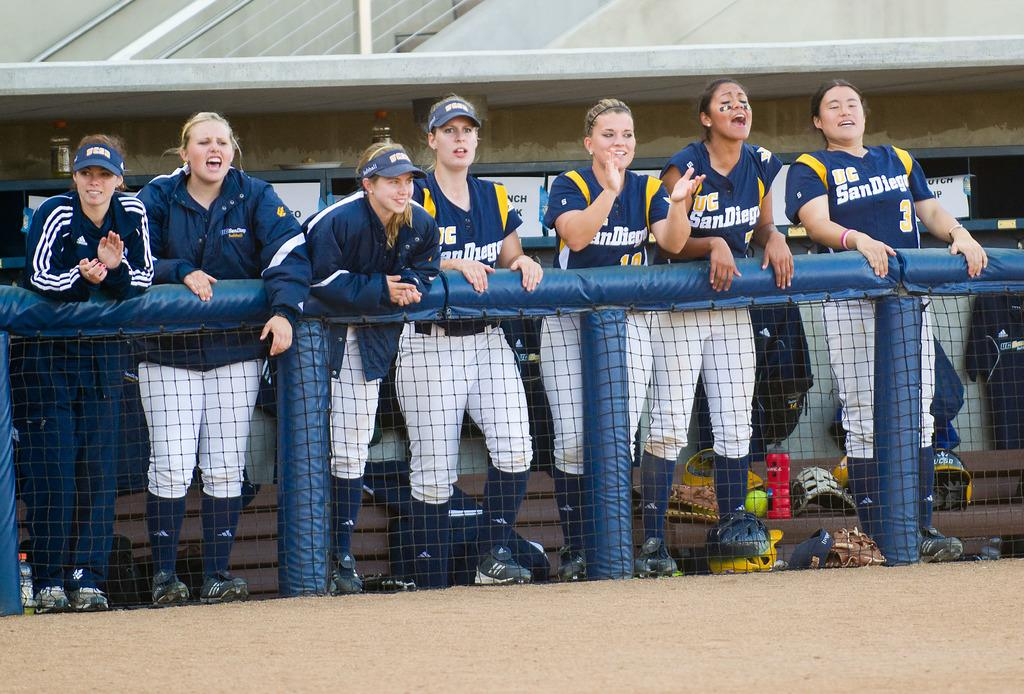<image>
Relay a brief, clear account of the picture shown. A group of women on the UC SanDiego softball team. 